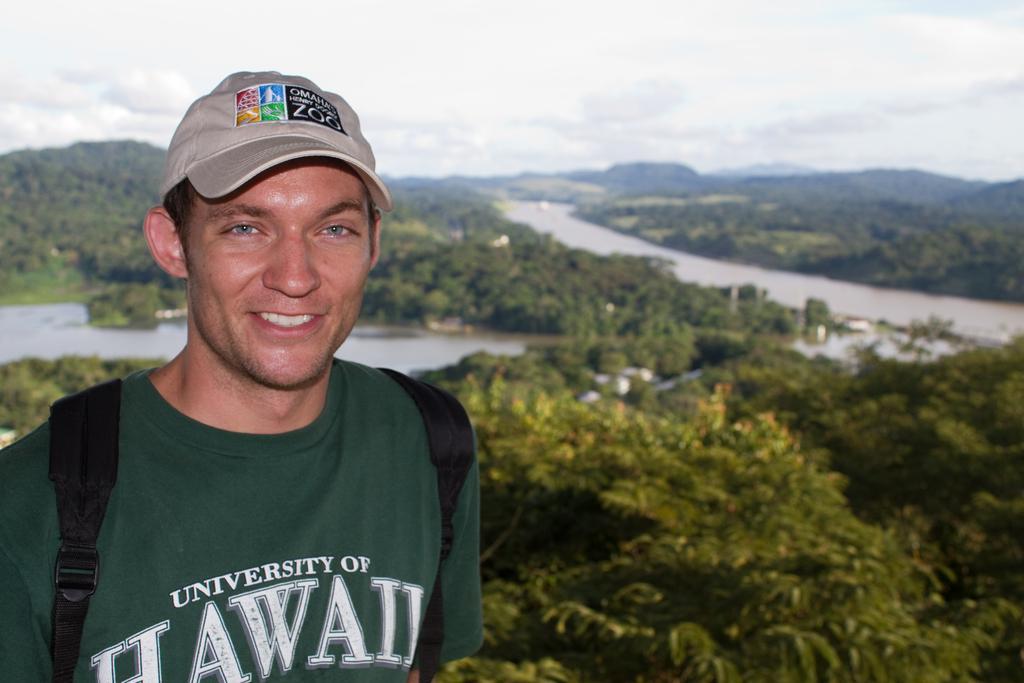What is the main subject of the image? There is a man standing in the image. What is the man wearing on his head? The man is wearing a cap. What can be seen in the background of the image? There are trees visible in the background of the image. What is the condition of the land in the image? There is water on the land in the image. What is visible at the top of the image? The sky is clear and visible at the top of the image. How many babies are playing with the rabbit in the image? There are no babies or rabbits present in the image. What type of journey is the man embarking on in the image? There is no indication of a journey in the image; it simply shows a man standing with trees and water in the background. 